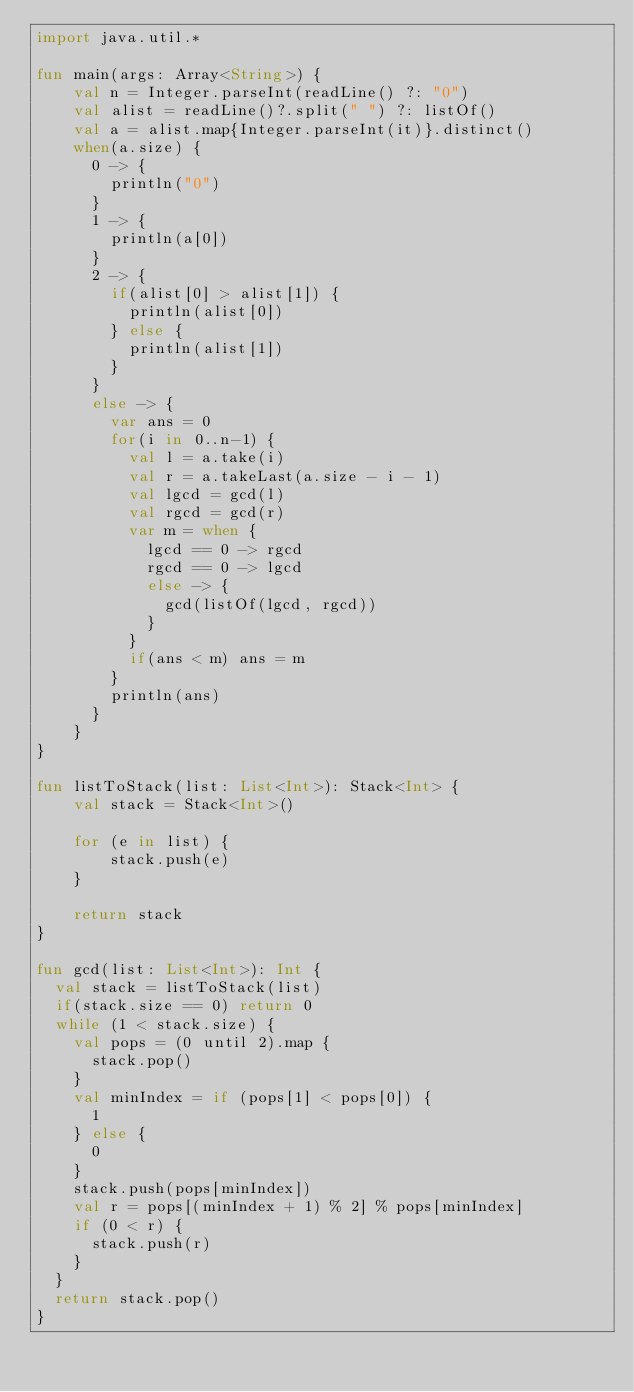Convert code to text. <code><loc_0><loc_0><loc_500><loc_500><_Kotlin_>import java.util.*

fun main(args: Array<String>) {
    val n = Integer.parseInt(readLine() ?: "0")
    val alist = readLine()?.split(" ") ?: listOf()
    val a = alist.map{Integer.parseInt(it)}.distinct()
    when(a.size) {
      0 -> {
        println("0")
      }
      1 -> {
        println(a[0])
      }
      2 -> {
        if(alist[0] > alist[1]) {
          println(alist[0])
        } else {
          println(alist[1])
        }
      }
      else -> {
        var ans = 0
        for(i in 0..n-1) {
          val l = a.take(i)
          val r = a.takeLast(a.size - i - 1)
          val lgcd = gcd(l)
          val rgcd = gcd(r)
          var m = when {
            lgcd == 0 -> rgcd
            rgcd == 0 -> lgcd
            else -> {
              gcd(listOf(lgcd, rgcd))
            }
          }
          if(ans < m) ans = m
        }
        println(ans)
      }
    }
}

fun listToStack(list: List<Int>): Stack<Int> {
    val stack = Stack<Int>()

    for (e in list) {
        stack.push(e)
    }

    return stack
}

fun gcd(list: List<Int>): Int {
  val stack = listToStack(list)
  if(stack.size == 0) return 0
  while (1 < stack.size) {
    val pops = (0 until 2).map {
      stack.pop()
    }
    val minIndex = if (pops[1] < pops[0]) {
      1
    } else {
      0
    }
    stack.push(pops[minIndex])
    val r = pops[(minIndex + 1) % 2] % pops[minIndex]
    if (0 < r) {
      stack.push(r)
    }
  }
  return stack.pop()
}
</code> 